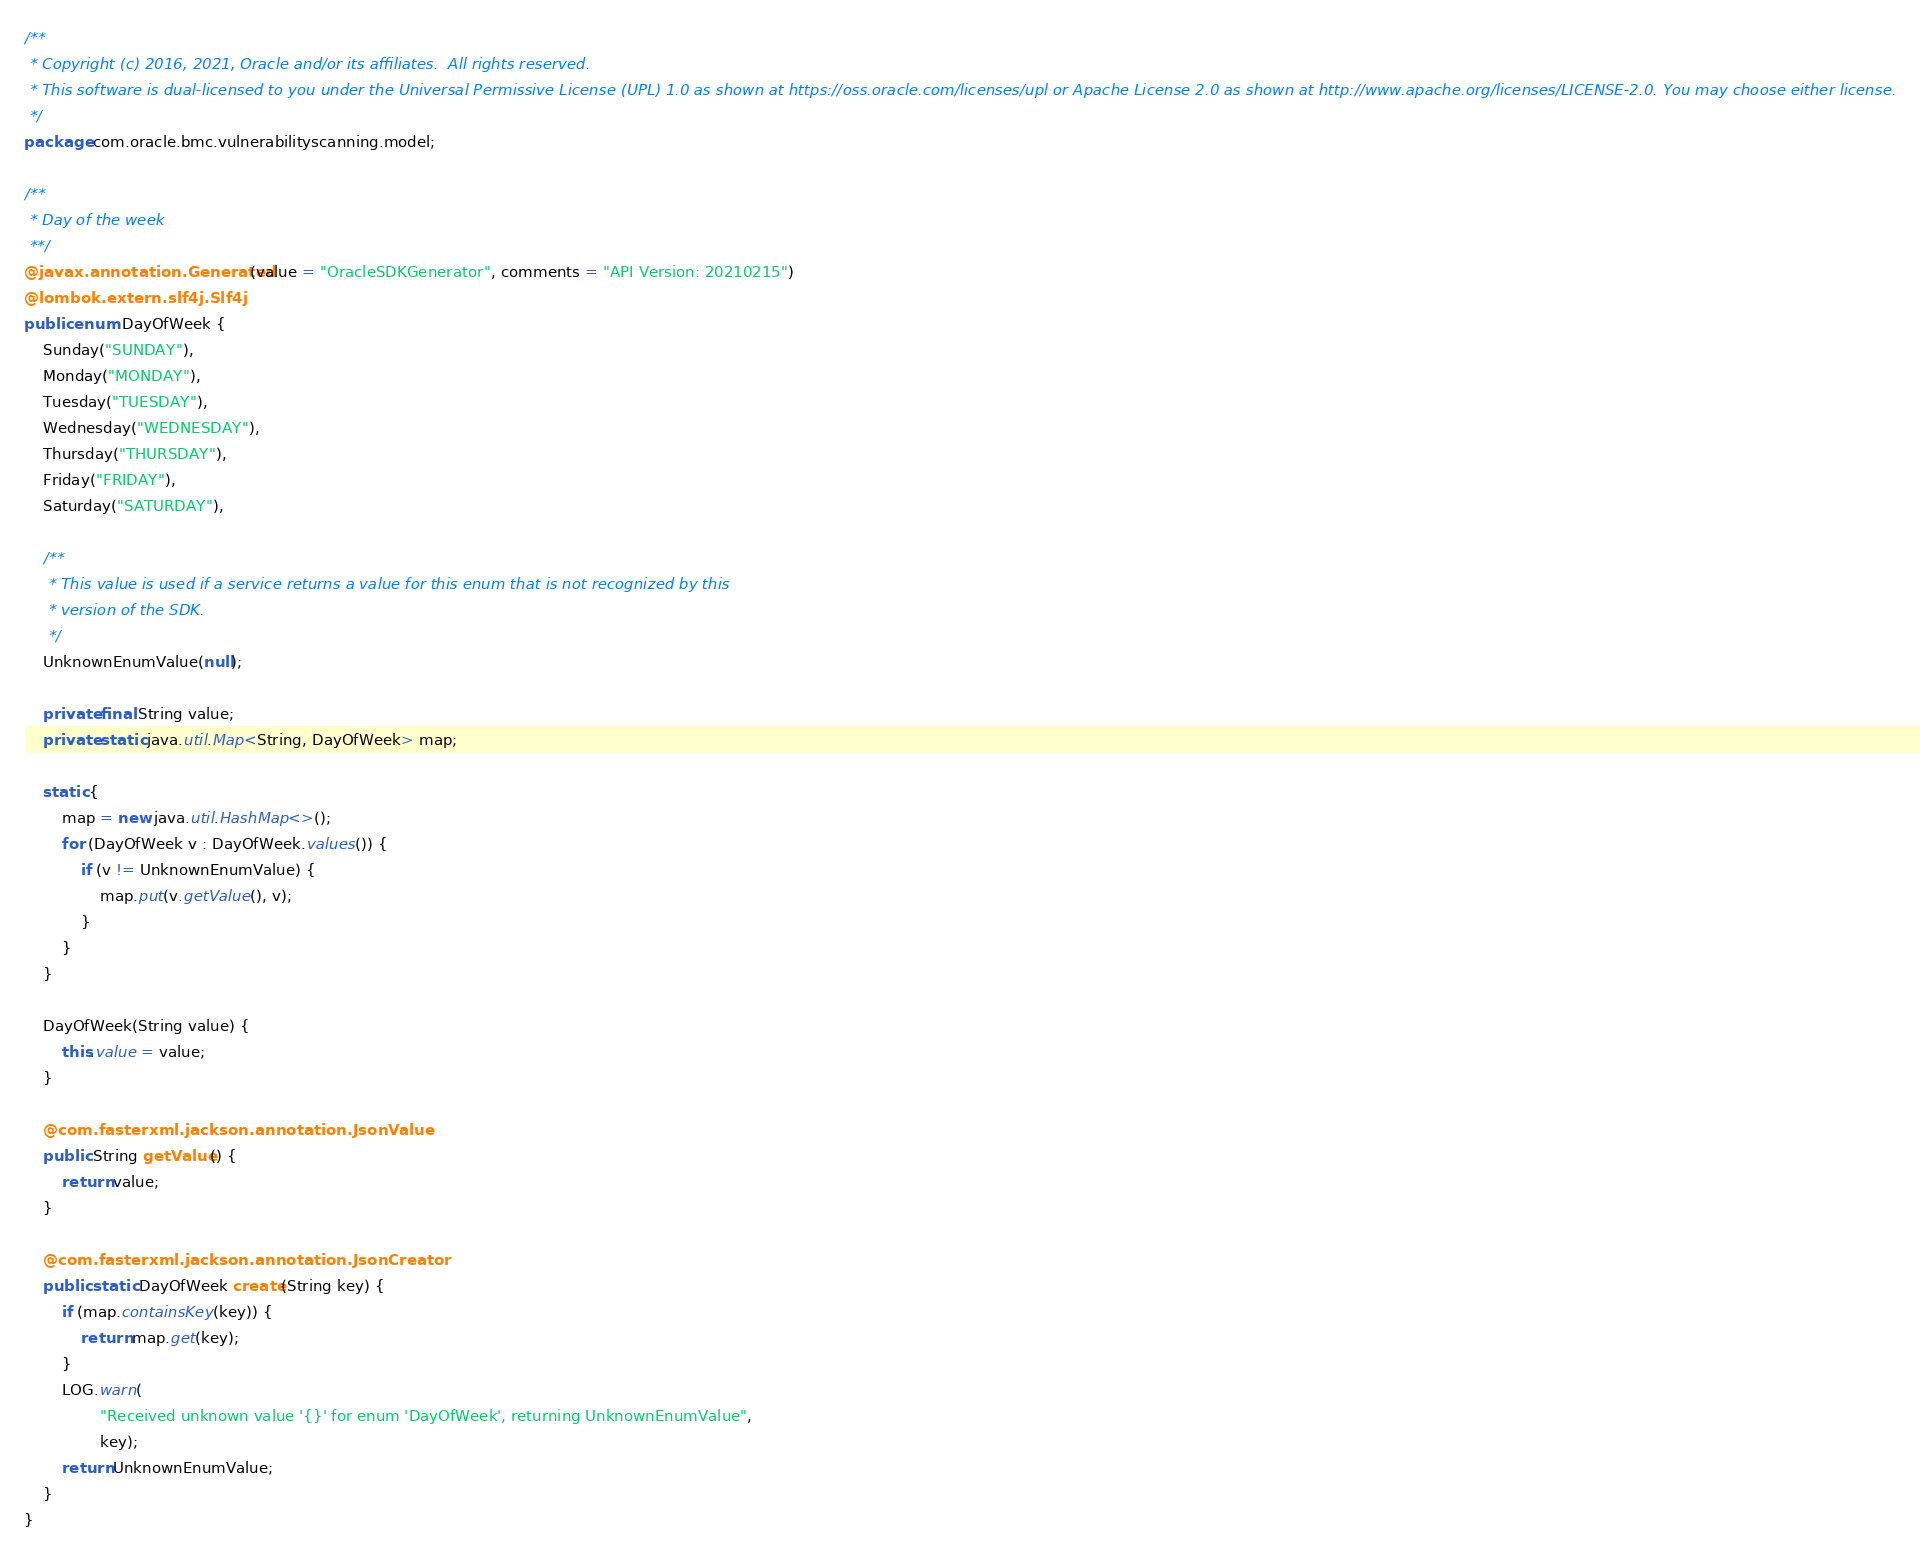Convert code to text. <code><loc_0><loc_0><loc_500><loc_500><_Java_>/**
 * Copyright (c) 2016, 2021, Oracle and/or its affiliates.  All rights reserved.
 * This software is dual-licensed to you under the Universal Permissive License (UPL) 1.0 as shown at https://oss.oracle.com/licenses/upl or Apache License 2.0 as shown at http://www.apache.org/licenses/LICENSE-2.0. You may choose either license.
 */
package com.oracle.bmc.vulnerabilityscanning.model;

/**
 * Day of the week
 **/
@javax.annotation.Generated(value = "OracleSDKGenerator", comments = "API Version: 20210215")
@lombok.extern.slf4j.Slf4j
public enum DayOfWeek {
    Sunday("SUNDAY"),
    Monday("MONDAY"),
    Tuesday("TUESDAY"),
    Wednesday("WEDNESDAY"),
    Thursday("THURSDAY"),
    Friday("FRIDAY"),
    Saturday("SATURDAY"),

    /**
     * This value is used if a service returns a value for this enum that is not recognized by this
     * version of the SDK.
     */
    UnknownEnumValue(null);

    private final String value;
    private static java.util.Map<String, DayOfWeek> map;

    static {
        map = new java.util.HashMap<>();
        for (DayOfWeek v : DayOfWeek.values()) {
            if (v != UnknownEnumValue) {
                map.put(v.getValue(), v);
            }
        }
    }

    DayOfWeek(String value) {
        this.value = value;
    }

    @com.fasterxml.jackson.annotation.JsonValue
    public String getValue() {
        return value;
    }

    @com.fasterxml.jackson.annotation.JsonCreator
    public static DayOfWeek create(String key) {
        if (map.containsKey(key)) {
            return map.get(key);
        }
        LOG.warn(
                "Received unknown value '{}' for enum 'DayOfWeek', returning UnknownEnumValue",
                key);
        return UnknownEnumValue;
    }
}
</code> 